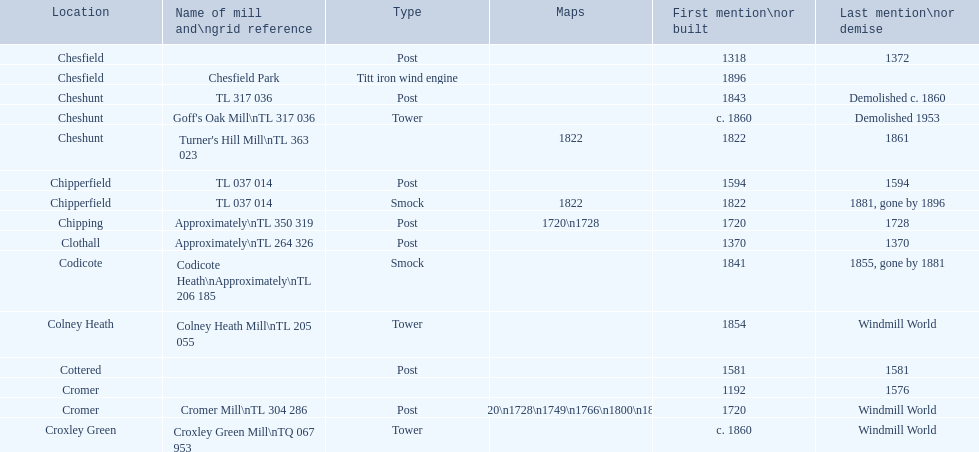How many sites lack photographic documentation? 14. 